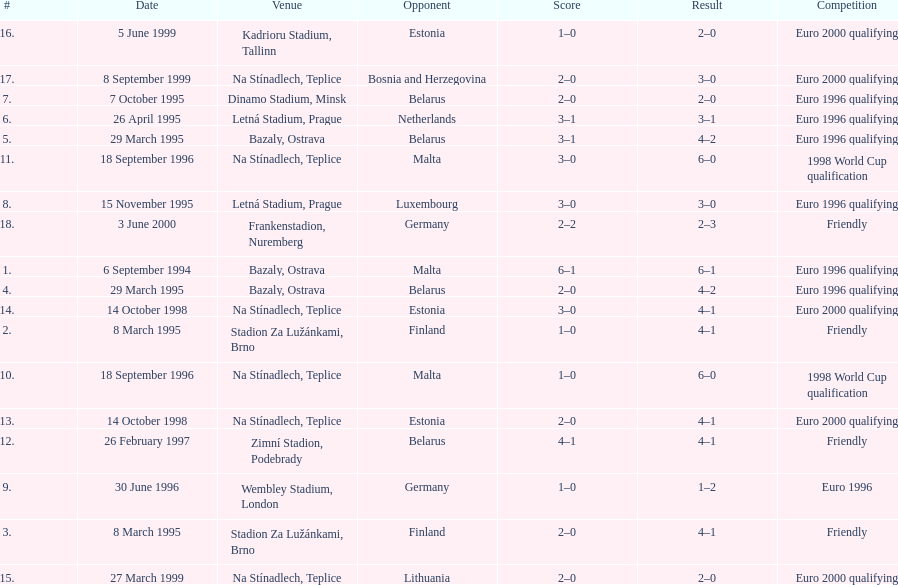List the opponents which are under the friendly competition. Finland, Belarus, Germany. Would you mind parsing the complete table? {'header': ['#', 'Date', 'Venue', 'Opponent', 'Score', 'Result', 'Competition'], 'rows': [['16.', '5 June 1999', 'Kadrioru Stadium, Tallinn', 'Estonia', '1–0', '2–0', 'Euro 2000 qualifying'], ['17.', '8 September 1999', 'Na Stínadlech, Teplice', 'Bosnia and Herzegovina', '2–0', '3–0', 'Euro 2000 qualifying'], ['7.', '7 October 1995', 'Dinamo Stadium, Minsk', 'Belarus', '2–0', '2–0', 'Euro 1996 qualifying'], ['6.', '26 April 1995', 'Letná Stadium, Prague', 'Netherlands', '3–1', '3–1', 'Euro 1996 qualifying'], ['5.', '29 March 1995', 'Bazaly, Ostrava', 'Belarus', '3–1', '4–2', 'Euro 1996 qualifying'], ['11.', '18 September 1996', 'Na Stínadlech, Teplice', 'Malta', '3–0', '6–0', '1998 World Cup qualification'], ['8.', '15 November 1995', 'Letná Stadium, Prague', 'Luxembourg', '3–0', '3–0', 'Euro 1996 qualifying'], ['18.', '3 June 2000', 'Frankenstadion, Nuremberg', 'Germany', '2–2', '2–3', 'Friendly'], ['1.', '6 September 1994', 'Bazaly, Ostrava', 'Malta', '6–1', '6–1', 'Euro 1996 qualifying'], ['4.', '29 March 1995', 'Bazaly, Ostrava', 'Belarus', '2–0', '4–2', 'Euro 1996 qualifying'], ['14.', '14 October 1998', 'Na Stínadlech, Teplice', 'Estonia', '3–0', '4–1', 'Euro 2000 qualifying'], ['2.', '8 March 1995', 'Stadion Za Lužánkami, Brno', 'Finland', '1–0', '4–1', 'Friendly'], ['10.', '18 September 1996', 'Na Stínadlech, Teplice', 'Malta', '1–0', '6–0', '1998 World Cup qualification'], ['13.', '14 October 1998', 'Na Stínadlech, Teplice', 'Estonia', '2–0', '4–1', 'Euro 2000 qualifying'], ['12.', '26 February 1997', 'Zimní Stadion, Podebrady', 'Belarus', '4–1', '4–1', 'Friendly'], ['9.', '30 June 1996', 'Wembley Stadium, London', 'Germany', '1–0', '1–2', 'Euro 1996'], ['3.', '8 March 1995', 'Stadion Za Lužánkami, Brno', 'Finland', '2–0', '4–1', 'Friendly'], ['15.', '27 March 1999', 'Na Stínadlech, Teplice', 'Lithuania', '2–0', '2–0', 'Euro 2000 qualifying']]} 